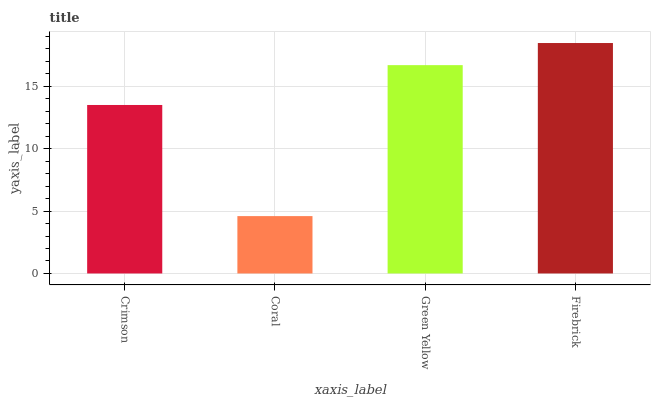Is Coral the minimum?
Answer yes or no. Yes. Is Firebrick the maximum?
Answer yes or no. Yes. Is Green Yellow the minimum?
Answer yes or no. No. Is Green Yellow the maximum?
Answer yes or no. No. Is Green Yellow greater than Coral?
Answer yes or no. Yes. Is Coral less than Green Yellow?
Answer yes or no. Yes. Is Coral greater than Green Yellow?
Answer yes or no. No. Is Green Yellow less than Coral?
Answer yes or no. No. Is Green Yellow the high median?
Answer yes or no. Yes. Is Crimson the low median?
Answer yes or no. Yes. Is Coral the high median?
Answer yes or no. No. Is Coral the low median?
Answer yes or no. No. 